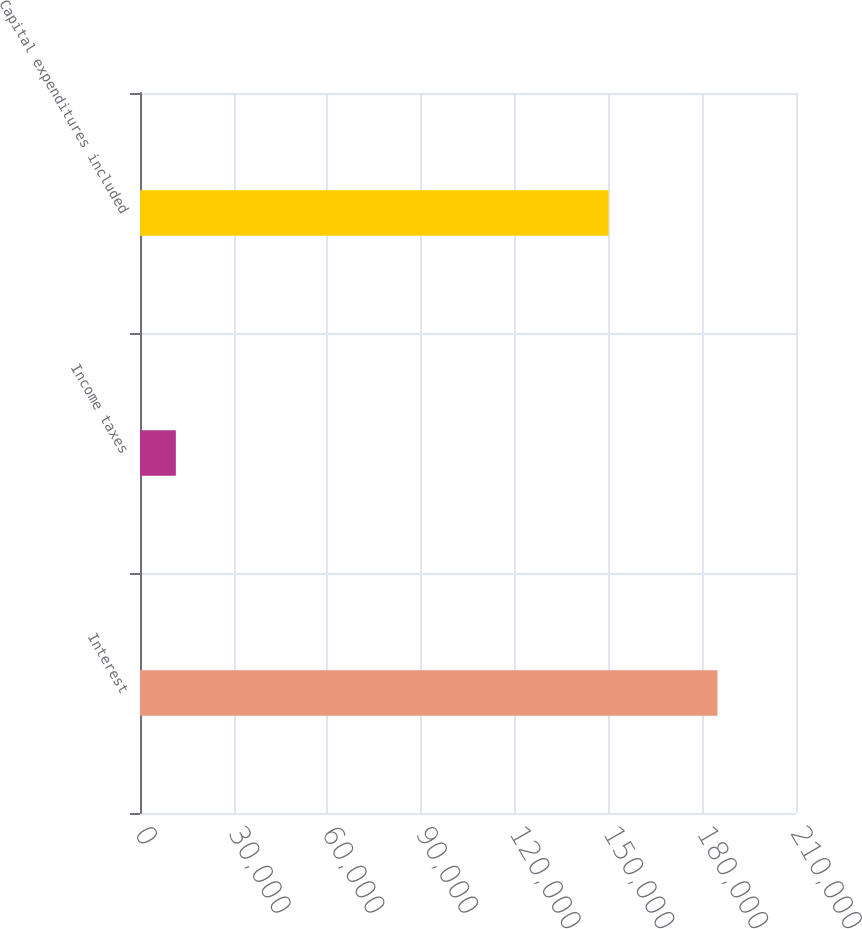Convert chart to OTSL. <chart><loc_0><loc_0><loc_500><loc_500><bar_chart><fcel>Interest<fcel>Income taxes<fcel>Capital expenditures included<nl><fcel>184852<fcel>11467<fcel>149993<nl></chart> 